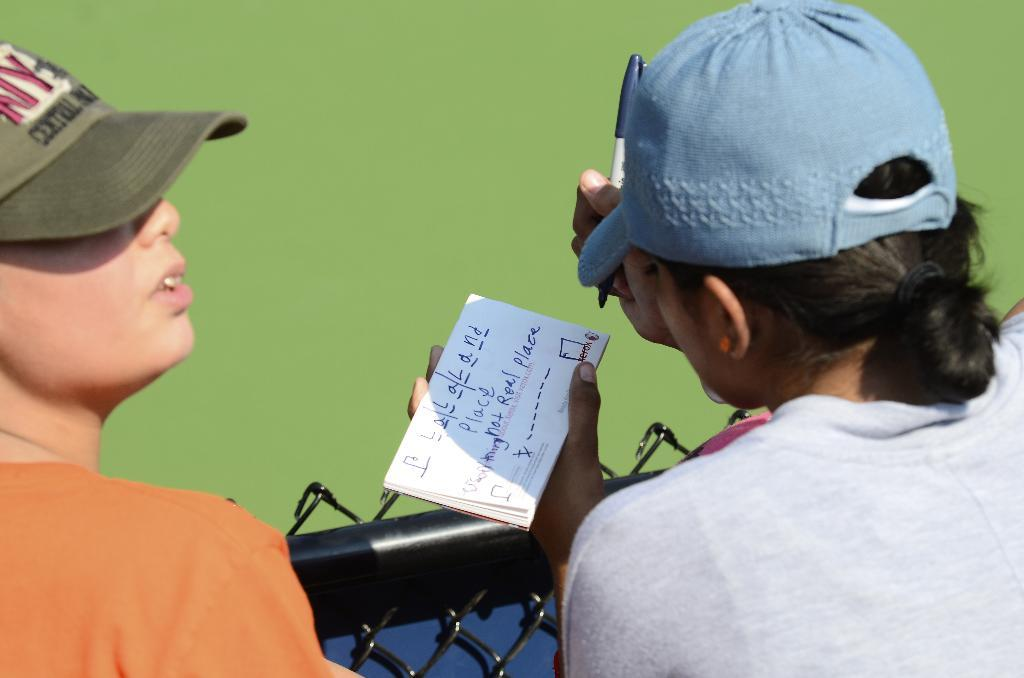How many people are in the image? There are two persons in the image. What are the persons wearing on their heads? Both persons are wearing caps. What can be seen in the image besides the people? There is a fence in the image. What color is predominant in the background of the image? The background of the image appears to be green. When do you think the image was taken? The image was likely taken during the day. Reasoning: Let' Let's think step by step in order to produce the conversation. We start by identifying the number of people in the image, which is two. Then, we describe their appearance, specifically mentioning the caps they are wearing. Next, we mention the fence as another object present in the image. We then describe the background color, which is green. Finally, we make an educated guess about the time of day the image was taken based on the available information. Absurd Question/Answer: What type of protest is happening in the image? There is no protest visible in the image. How many boys are present in the image? The provided facts do not specify the gender of the persons in the image, so we cannot determine the number of boys. What is the hammer being used for in the image? There is no hammer present in the image. 